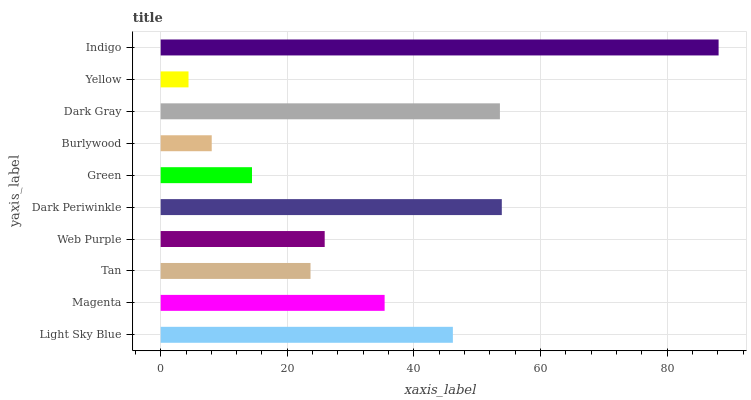Is Yellow the minimum?
Answer yes or no. Yes. Is Indigo the maximum?
Answer yes or no. Yes. Is Magenta the minimum?
Answer yes or no. No. Is Magenta the maximum?
Answer yes or no. No. Is Light Sky Blue greater than Magenta?
Answer yes or no. Yes. Is Magenta less than Light Sky Blue?
Answer yes or no. Yes. Is Magenta greater than Light Sky Blue?
Answer yes or no. No. Is Light Sky Blue less than Magenta?
Answer yes or no. No. Is Magenta the high median?
Answer yes or no. Yes. Is Web Purple the low median?
Answer yes or no. Yes. Is Green the high median?
Answer yes or no. No. Is Indigo the low median?
Answer yes or no. No. 